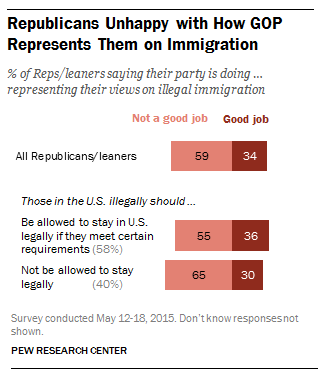Draw attention to some important aspects in this diagram. According to a recent poll, only 0.34 out of all Republicans believe that their party is doing a good job. According to the data, the share of all Republicans who say their party is doing a good job is 0.25. 